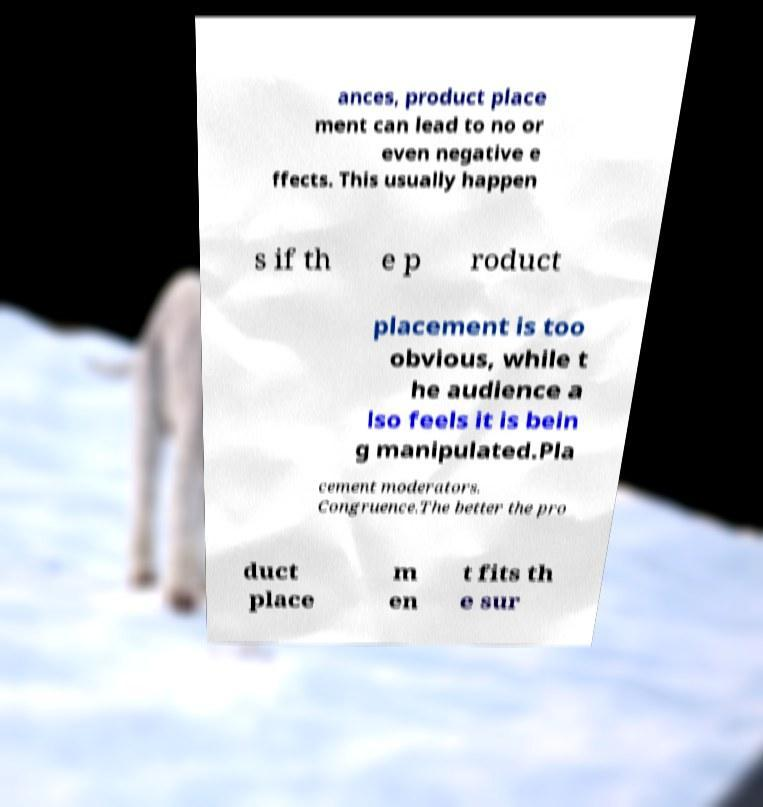For documentation purposes, I need the text within this image transcribed. Could you provide that? ances, product place ment can lead to no or even negative e ffects. This usually happen s if th e p roduct placement is too obvious, while t he audience a lso feels it is bein g manipulated.Pla cement moderators. Congruence.The better the pro duct place m en t fits th e sur 